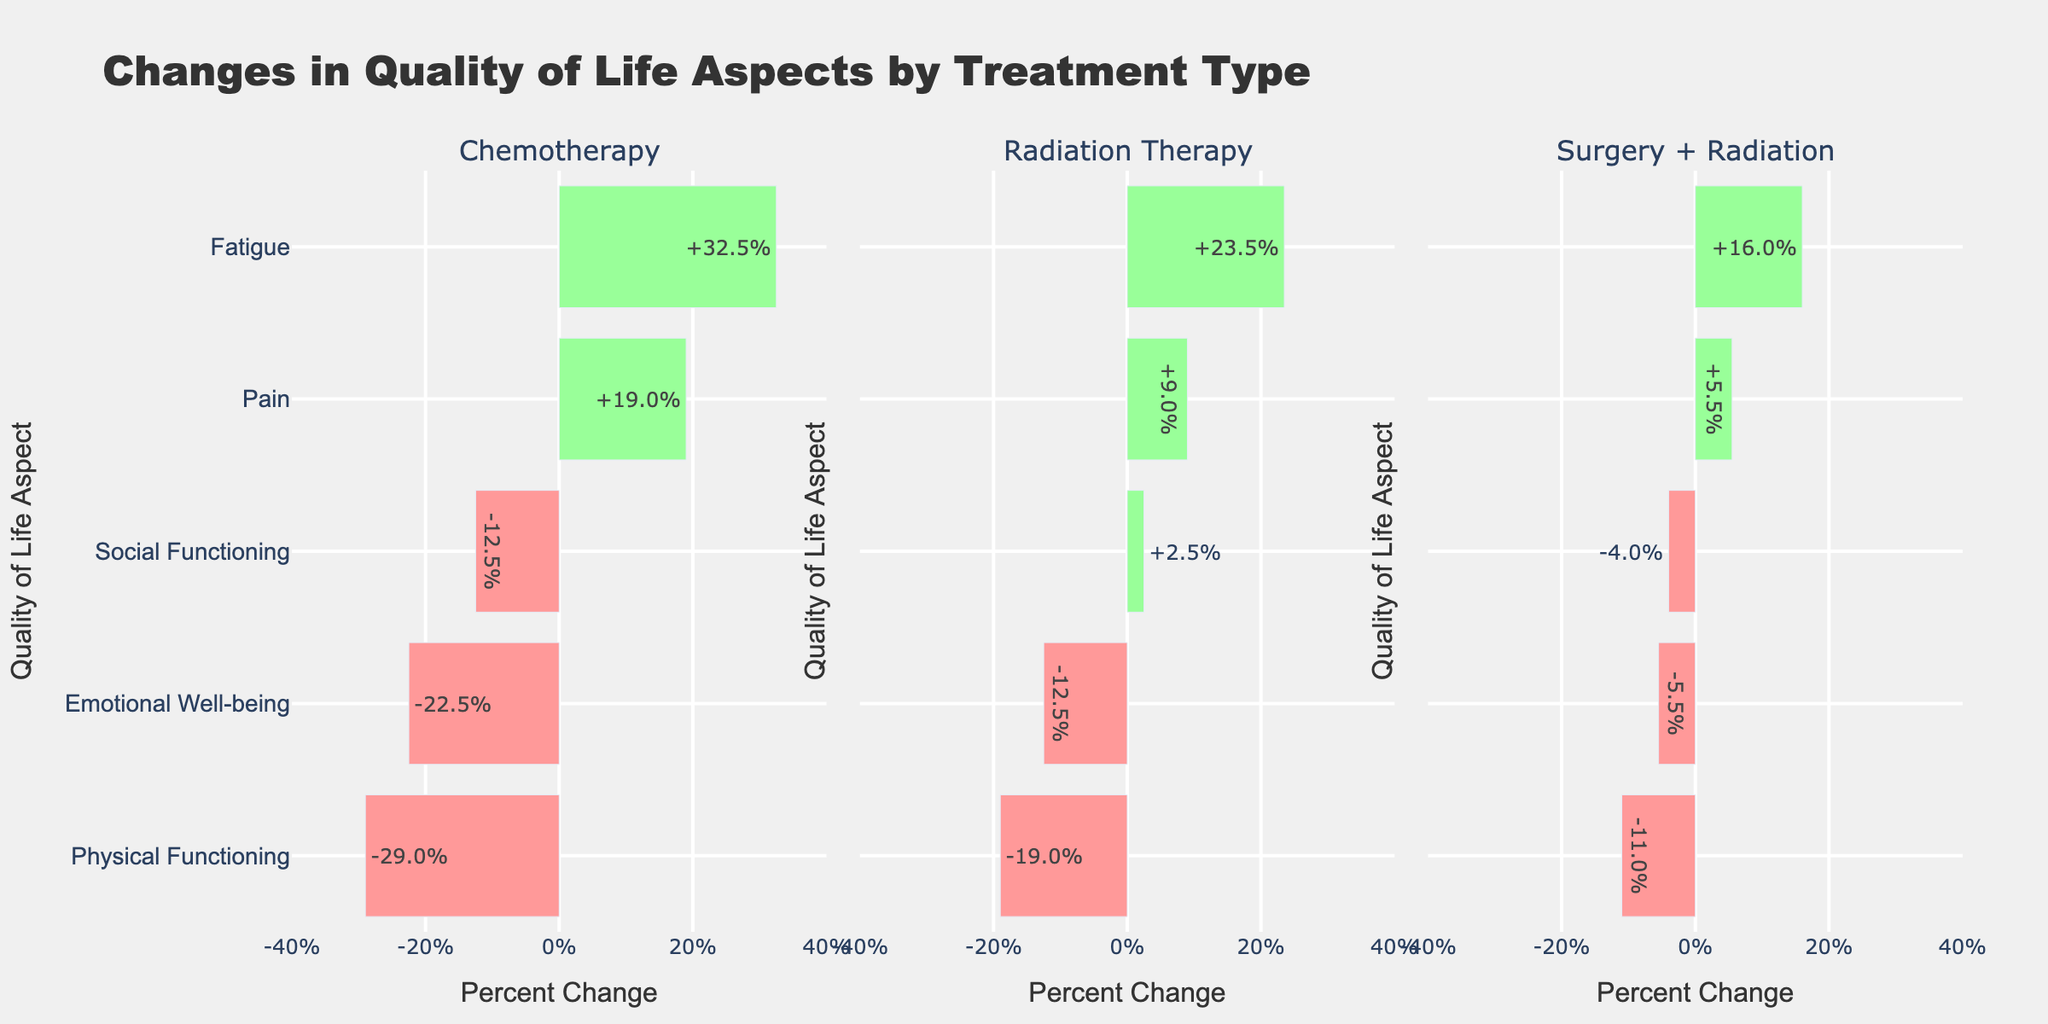What is the average percent change in Emotional Well-being for each treatment type? To find the average percent change in Emotional Well-being, we look at each bar under Emotional Well-being for each treatment type: Radiation Therapy (-15% and -10% -> average = (-15 + -10) / 2 = -12.5%), Chemotherapy (-25% and -20% -> average = (-25 + -20) / 2 = -22.5%), Surgery + Radiation (-5% and -6% -> average = (-5 + -6) / 2 = -5.5%)
Answer: Radiation Therapy: -12.5%, Chemotherapy: -22.5%, Surgery + Radiation: -5.5% Which quality of life aspect shows the largest improvement in Radiation Therapy? To find the largest improvement, we look for the highest positive percent change in Radiation Therapy. Fatigue shows +25% and Pain shows +10%, Social Functioning shows +5%, so Fatigue has the largest improvement at +25%.
Answer: Fatigue Compare the percent change in Physical Functioning between Chemotherapy and Surgery + Radiation. Which one has a larger negative impact? To compare, look at the bars for Physical Functioning. Chemotherapy shows -30% while Surgery + Radiation shows -10% and -12%. Chemotherapy has the larger negative impact with -30%.
Answer: Chemotherapy What is the average percent change in Pain across all treatment types? To find the average percent change in Pain, average the percent changes across all treatment types: Radiation Therapy (10% + 8% = 18%/2 = 9%), Chemotherapy (20% + 18% = 38%/2 = 19%), Surgery + Radiation (5% + 6% = 11%/2 = 5.5%), then average those: (9 + 19 + 5.5)/3 = 11.17%.
Answer: 11.17% Which treatment type shows the least negative impact on Emotional Well-being? The least negative impact refers to the smallest negative percent change. Radiation Therapy shows -15% and -10%, Chemotherapy shows -25% and -20%, Surgery + Radiation shows -5% and -6%. Surgery + Radiation shows the smallest negative change with -5%.
Answer: Surgery + Radiation Compare the overall pattern of Social Functioning across the treatment types. What do you observe? By comparing the Social Functioning bars, we see: Radiation Therapy (0% and +5%), Chemotherapy (-15% and -10%), Surgery + Radiation (-5% and -3%). Radiation Therapy shows no negative change, Chemotherapy shows moderate negative change, and Surgery + Radiation shows slight negative change. Radiation Therapy appears to maintain or slightly improve social functioning compared to other treatments.
Answer: Radiation Therapy shows no negative change, others show negative change Which treatment type has the highest average positive percent change across all quality of life aspects? To find the highest average positive percent change, calculate the average for positive changes in each treatment: Radiation Therapy (25+10+5+22+8)/5 = 70/5 = 14%, Chemotherapy (35+20+30+18)/4 = 103/4 = 25.75%, Surgery + Radiation (15+5+17+6)/4 = 43/4 = 10.75%. Chemotherapy has the highest average positive percent change.
Answer: Chemotherapy 